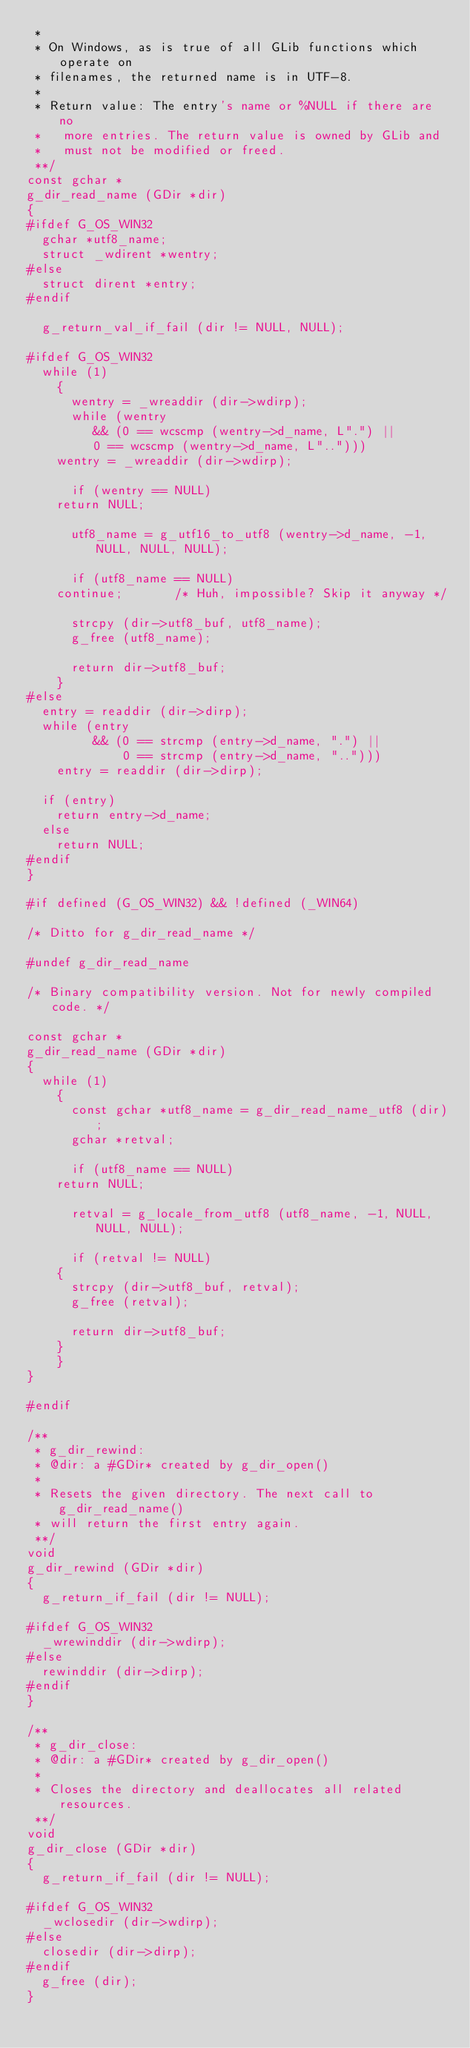<code> <loc_0><loc_0><loc_500><loc_500><_C_> *
 * On Windows, as is true of all GLib functions which operate on
 * filenames, the returned name is in UTF-8.
 *
 * Return value: The entry's name or %NULL if there are no
 *   more entries. The return value is owned by GLib and
 *   must not be modified or freed.
 **/
const gchar *
g_dir_read_name (GDir *dir)
{
#ifdef G_OS_WIN32
  gchar *utf8_name;
  struct _wdirent *wentry;
#else
  struct dirent *entry;
#endif

  g_return_val_if_fail (dir != NULL, NULL);

#ifdef G_OS_WIN32
  while (1)
    {
      wentry = _wreaddir (dir->wdirp);
      while (wentry 
	     && (0 == wcscmp (wentry->d_name, L".") ||
		 0 == wcscmp (wentry->d_name, L"..")))
	wentry = _wreaddir (dir->wdirp);

      if (wentry == NULL)
	return NULL;

      utf8_name = g_utf16_to_utf8 (wentry->d_name, -1, NULL, NULL, NULL);

      if (utf8_name == NULL)
	continue;		/* Huh, impossible? Skip it anyway */

      strcpy (dir->utf8_buf, utf8_name);
      g_free (utf8_name);

      return dir->utf8_buf;
    }
#else
  entry = readdir (dir->dirp);
  while (entry 
         && (0 == strcmp (entry->d_name, ".") ||
             0 == strcmp (entry->d_name, "..")))
    entry = readdir (dir->dirp);

  if (entry)
    return entry->d_name;
  else
    return NULL;
#endif
}

#if defined (G_OS_WIN32) && !defined (_WIN64)

/* Ditto for g_dir_read_name */

#undef g_dir_read_name

/* Binary compatibility version. Not for newly compiled code. */

const gchar *
g_dir_read_name (GDir *dir)
{
  while (1)
    {
      const gchar *utf8_name = g_dir_read_name_utf8 (dir);
      gchar *retval;
      
      if (utf8_name == NULL)
	return NULL;

      retval = g_locale_from_utf8 (utf8_name, -1, NULL, NULL, NULL);

      if (retval != NULL)
	{
	  strcpy (dir->utf8_buf, retval);
	  g_free (retval);

	  return dir->utf8_buf;
	}
    }
}

#endif

/**
 * g_dir_rewind:
 * @dir: a #GDir* created by g_dir_open()
 *
 * Resets the given directory. The next call to g_dir_read_name()
 * will return the first entry again.
 **/
void
g_dir_rewind (GDir *dir)
{
  g_return_if_fail (dir != NULL);
  
#ifdef G_OS_WIN32
  _wrewinddir (dir->wdirp);
#else
  rewinddir (dir->dirp);
#endif
}

/**
 * g_dir_close:
 * @dir: a #GDir* created by g_dir_open()
 *
 * Closes the directory and deallocates all related resources.
 **/
void
g_dir_close (GDir *dir)
{
  g_return_if_fail (dir != NULL);

#ifdef G_OS_WIN32
  _wclosedir (dir->wdirp);
#else
  closedir (dir->dirp);
#endif
  g_free (dir);
}
</code> 